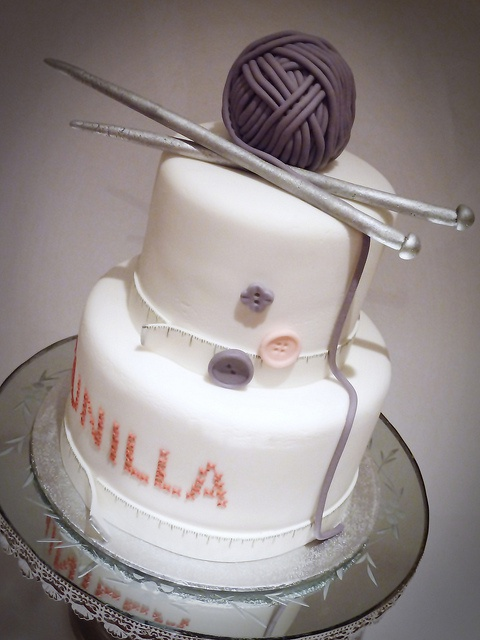Describe the objects in this image and their specific colors. I can see a cake in black, lightgray, darkgray, and gray tones in this image. 